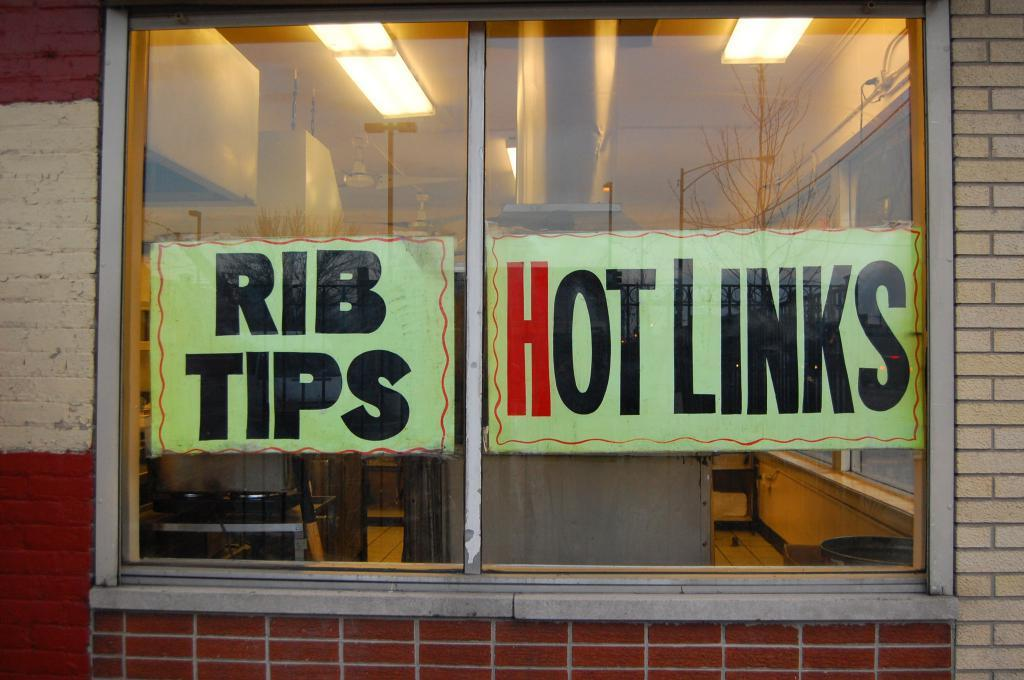What is the main feature in the middle of the image? There is a glass window in the middle of the image. What can be seen on the glass window? There are labels on the window. What is visible at the top of the image? There are lights at the top of the image. What is located beside the window? There is a wall beside the window. Can you point out the water fountain in the image? There is no water fountain present in the image. 